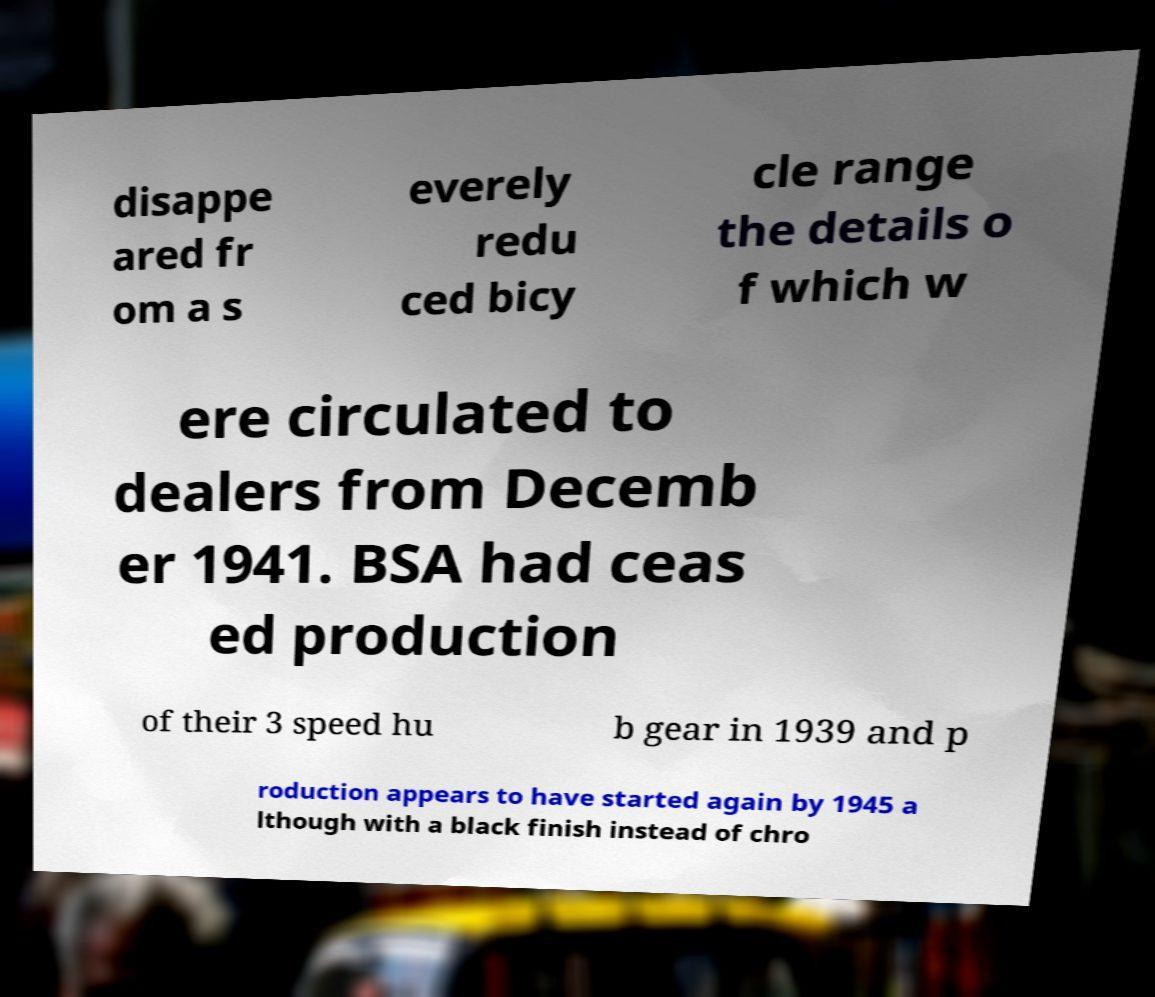I need the written content from this picture converted into text. Can you do that? disappe ared fr om a s everely redu ced bicy cle range the details o f which w ere circulated to dealers from Decemb er 1941. BSA had ceas ed production of their 3 speed hu b gear in 1939 and p roduction appears to have started again by 1945 a lthough with a black finish instead of chro 